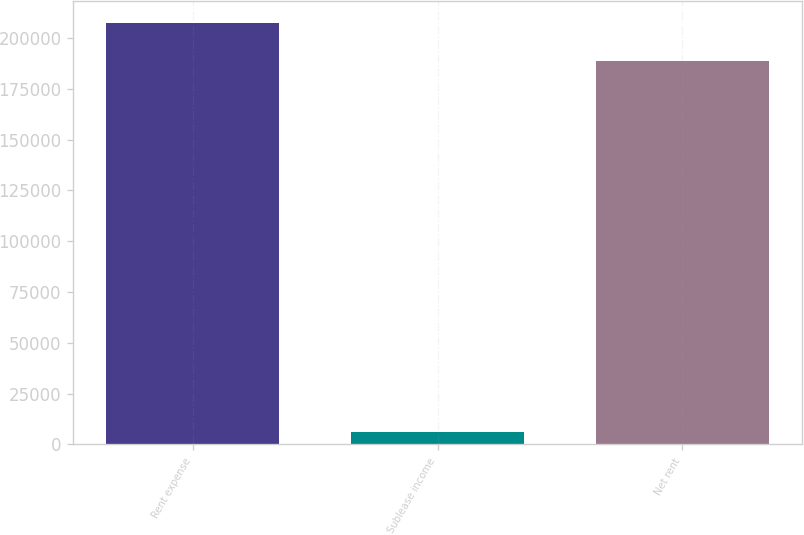Convert chart. <chart><loc_0><loc_0><loc_500><loc_500><bar_chart><fcel>Rent expense<fcel>Sublease income<fcel>Net rent<nl><fcel>207563<fcel>6102<fcel>188694<nl></chart> 